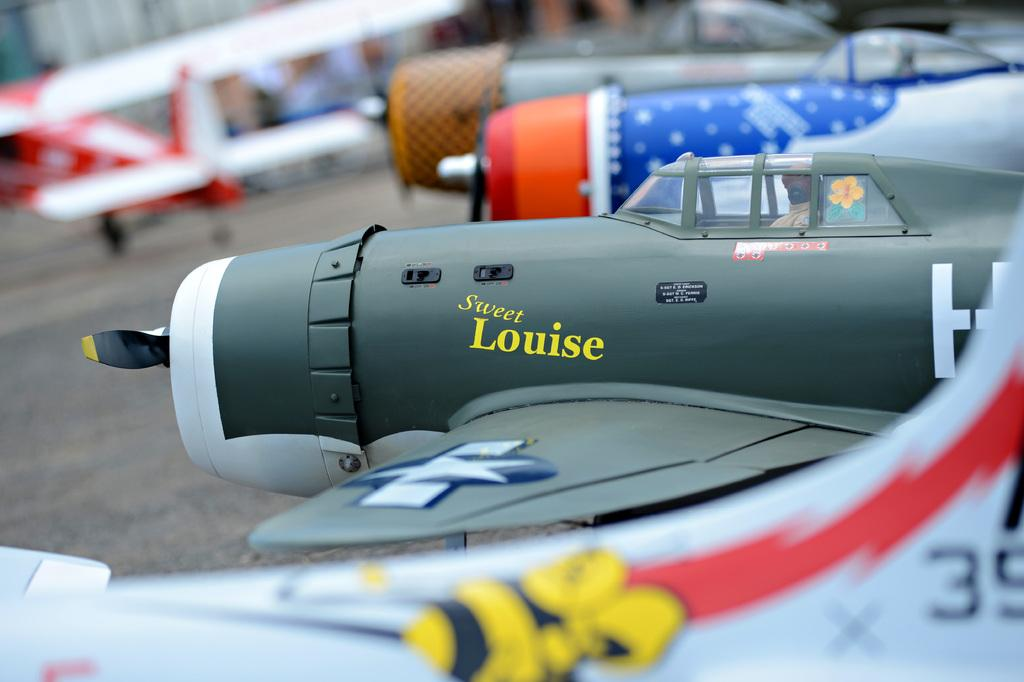Provide a one-sentence caption for the provided image. A gray and white model fighter plane named Sweet Louise. 